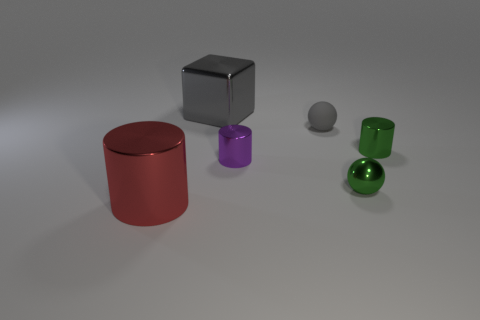There is a green shiny object that is left of the small metal cylinder that is right of the gray object in front of the big gray shiny block; what size is it?
Ensure brevity in your answer.  Small. There is a red metallic object; what number of tiny things are on the right side of it?
Ensure brevity in your answer.  4. There is a big object behind the big metal object that is on the left side of the big block; what is it made of?
Your response must be concise. Metal. Is there any other thing that has the same size as the metal block?
Give a very brief answer. Yes. Do the green cylinder and the block have the same size?
Your response must be concise. No. How many objects are either tiny green objects that are in front of the tiny rubber sphere or objects that are in front of the small gray thing?
Offer a terse response. 4. Are there more small green balls that are to the left of the small purple shiny thing than large blocks?
Your response must be concise. No. How many other objects are the same shape as the large red shiny thing?
Offer a terse response. 2. There is a thing that is both to the right of the tiny purple cylinder and in front of the tiny purple shiny thing; what is its material?
Give a very brief answer. Metal. How many objects are red shiny things or small metallic spheres?
Offer a terse response. 2. 